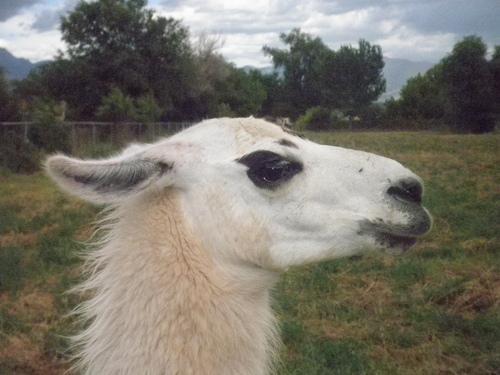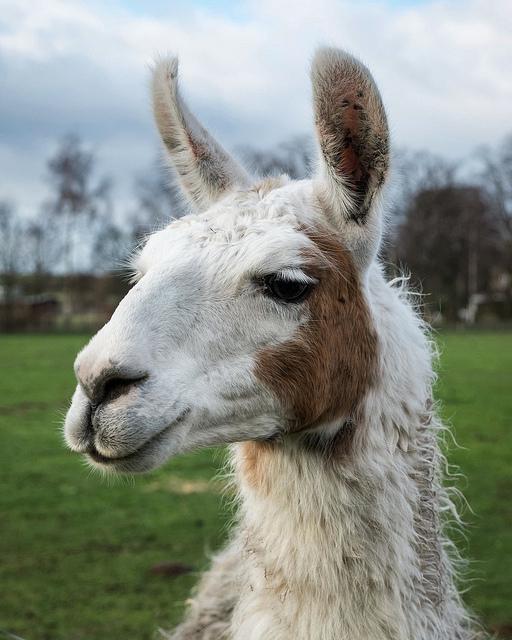The first image is the image on the left, the second image is the image on the right. For the images shown, is this caption "There are two llamas in the left image and one llama in the right image." true? Answer yes or no. No. The first image is the image on the left, the second image is the image on the right. Considering the images on both sides, is "Each llama in the pair of images is an adult llama." valid? Answer yes or no. Yes. 